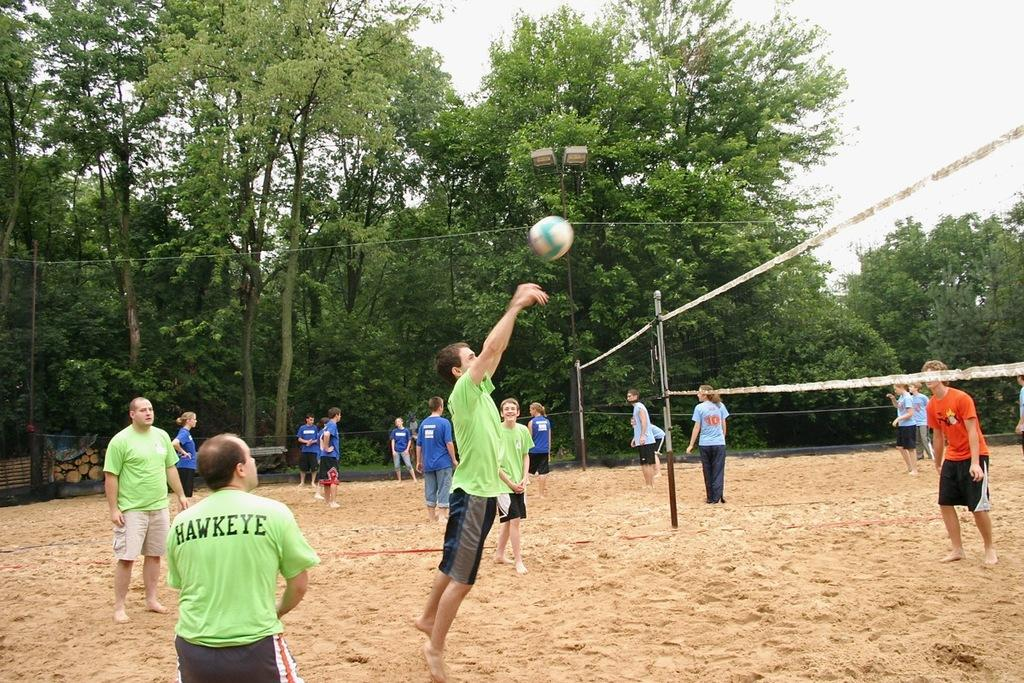<image>
Give a short and clear explanation of the subsequent image. A man named Hawkeye is playing volleyball with a bunch of other people. 